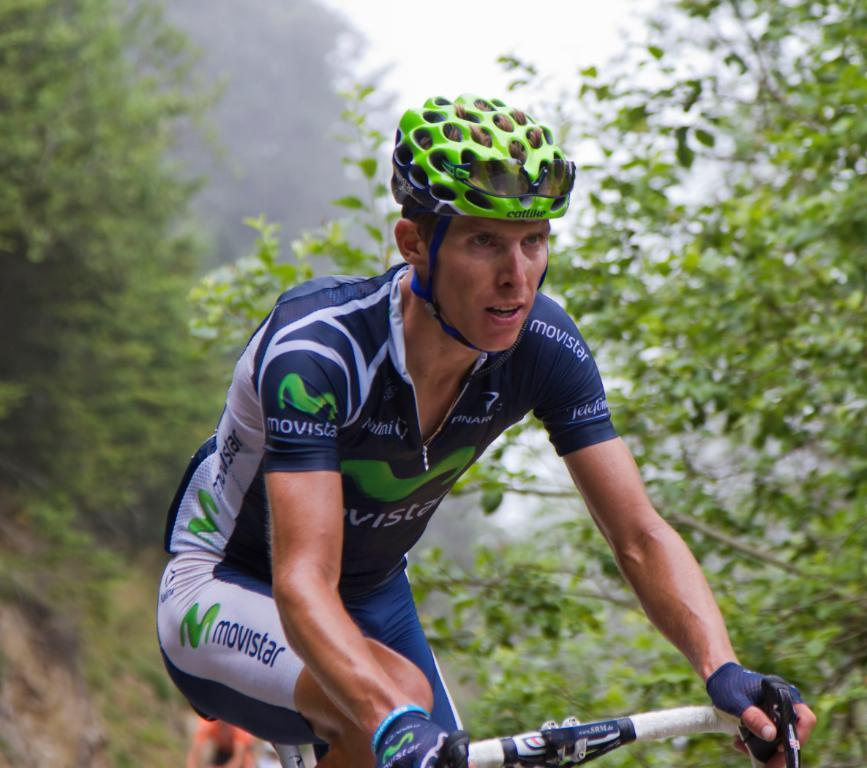What is the main subject of the image? There is a person in the image. What is the person doing in the image? The person is riding a cycle. What safety gear is the person wearing? The person is wearing a helmet. What can be seen in the background of the image? There is sky visible in the background of the image. What is the condition of the sky in the image? There are clouds in the sky. What type of earth can be seen in the image? There is no earth visible in the image; it features a person riding a cycle with a sky background. What kind of apparatus is being used by the person in the image? The person is riding a cycle, which is the main apparatus visible in the image. 